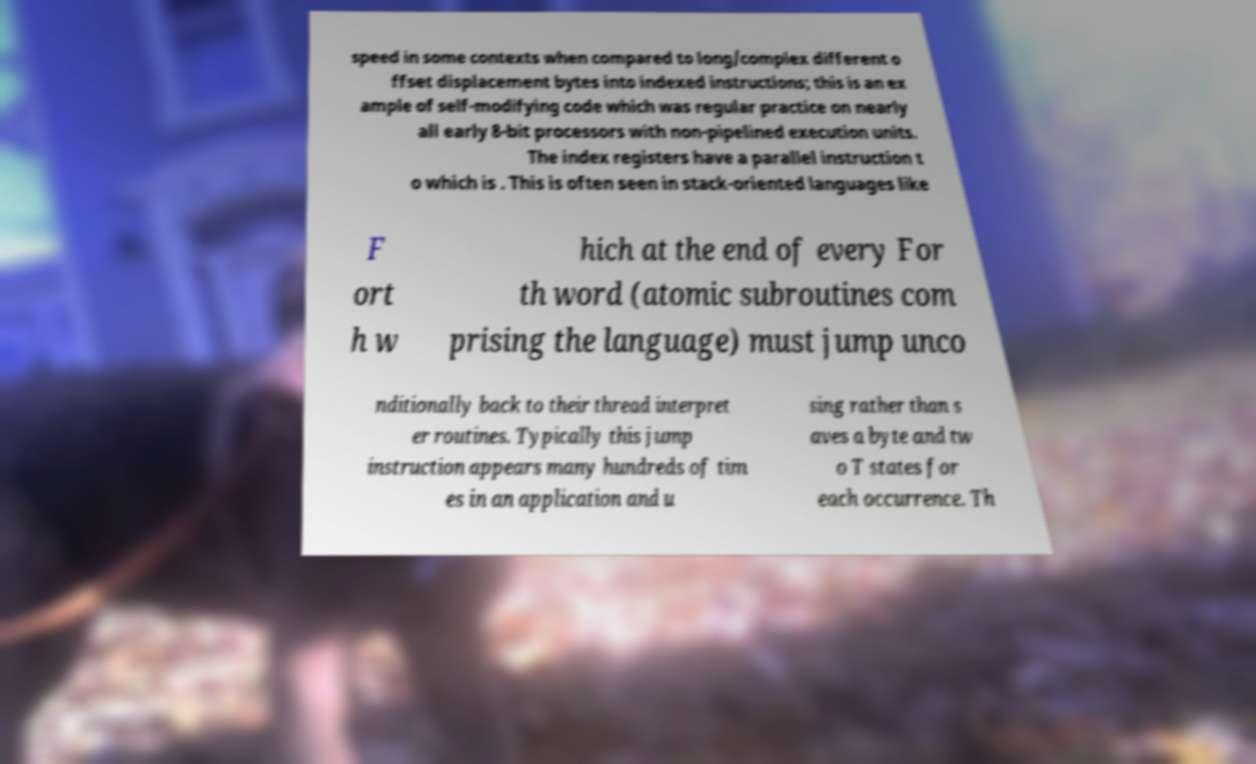Can you read and provide the text displayed in the image?This photo seems to have some interesting text. Can you extract and type it out for me? speed in some contexts when compared to long/complex different o ffset displacement bytes into indexed instructions; this is an ex ample of self-modifying code which was regular practice on nearly all early 8-bit processors with non-pipelined execution units. The index registers have a parallel instruction t o which is . This is often seen in stack-oriented languages like F ort h w hich at the end of every For th word (atomic subroutines com prising the language) must jump unco nditionally back to their thread interpret er routines. Typically this jump instruction appears many hundreds of tim es in an application and u sing rather than s aves a byte and tw o T states for each occurrence. Th 